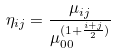<formula> <loc_0><loc_0><loc_500><loc_500>\eta _ { i j } = \frac { \mu _ { i j } } { \mu _ { 0 0 } ^ { ( 1 + \frac { i + j } { 2 } ) } }</formula> 